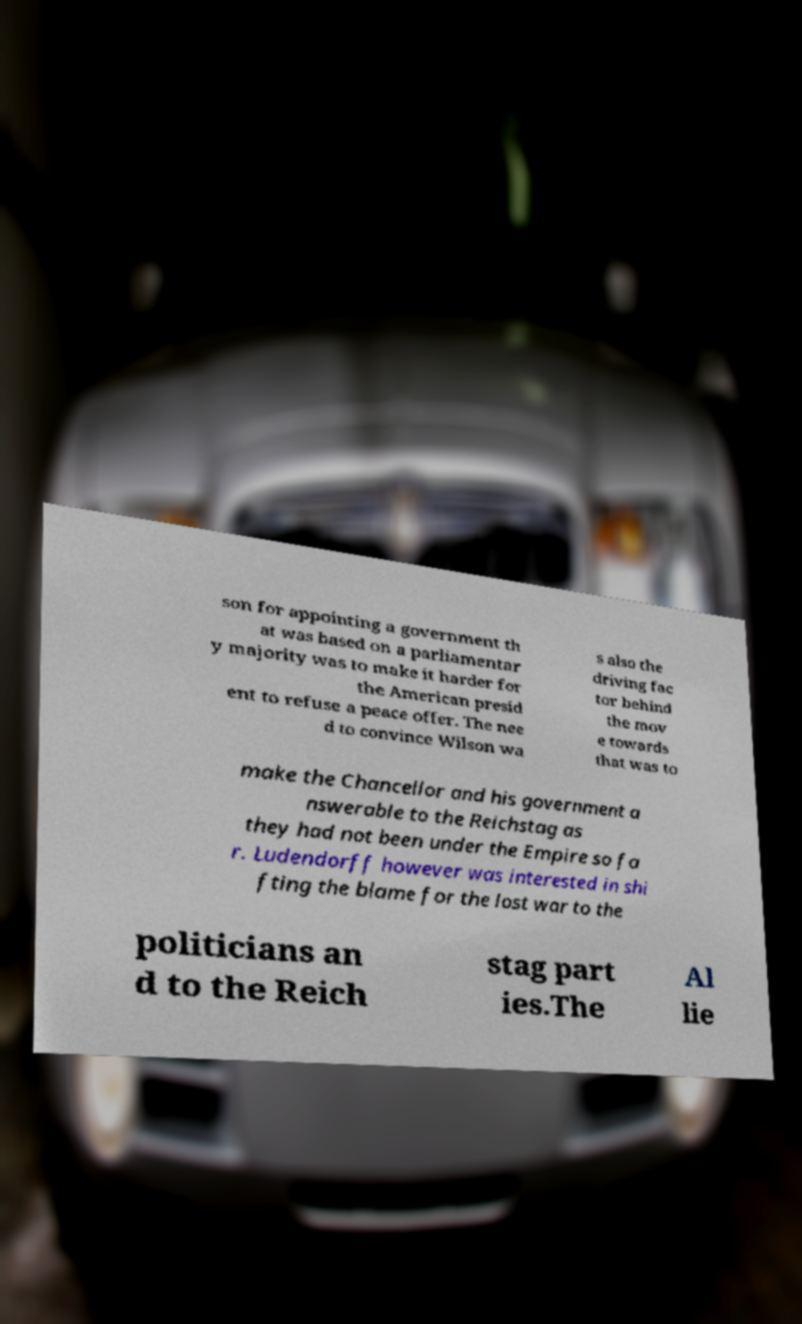There's text embedded in this image that I need extracted. Can you transcribe it verbatim? son for appointing a government th at was based on a parliamentar y majority was to make it harder for the American presid ent to refuse a peace offer. The nee d to convince Wilson wa s also the driving fac tor behind the mov e towards that was to make the Chancellor and his government a nswerable to the Reichstag as they had not been under the Empire so fa r. Ludendorff however was interested in shi fting the blame for the lost war to the politicians an d to the Reich stag part ies.The Al lie 